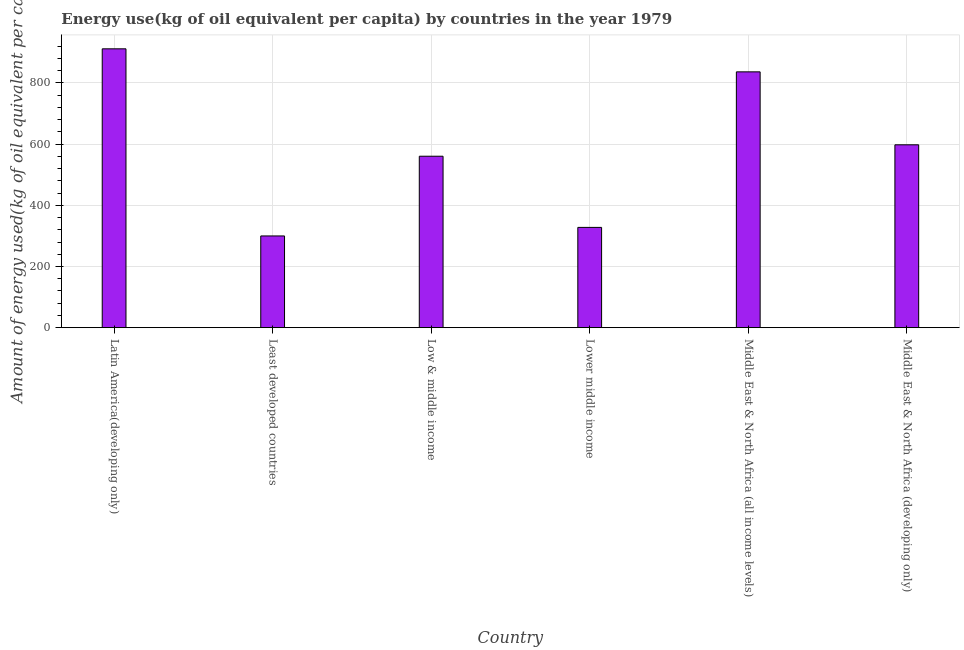Does the graph contain any zero values?
Provide a short and direct response. No. What is the title of the graph?
Provide a succinct answer. Energy use(kg of oil equivalent per capita) by countries in the year 1979. What is the label or title of the Y-axis?
Make the answer very short. Amount of energy used(kg of oil equivalent per capita). What is the amount of energy used in Middle East & North Africa (developing only)?
Your answer should be very brief. 597.81. Across all countries, what is the maximum amount of energy used?
Offer a very short reply. 911.58. Across all countries, what is the minimum amount of energy used?
Offer a terse response. 299.85. In which country was the amount of energy used maximum?
Offer a very short reply. Latin America(developing only). In which country was the amount of energy used minimum?
Your answer should be very brief. Least developed countries. What is the sum of the amount of energy used?
Provide a short and direct response. 3533.73. What is the difference between the amount of energy used in Latin America(developing only) and Low & middle income?
Your response must be concise. 351.13. What is the average amount of energy used per country?
Keep it short and to the point. 588.96. What is the median amount of energy used?
Give a very brief answer. 579.13. What is the ratio of the amount of energy used in Latin America(developing only) to that in Middle East & North Africa (developing only)?
Offer a very short reply. 1.52. Is the difference between the amount of energy used in Least developed countries and Middle East & North Africa (all income levels) greater than the difference between any two countries?
Offer a very short reply. No. What is the difference between the highest and the second highest amount of energy used?
Provide a short and direct response. 75.33. What is the difference between the highest and the lowest amount of energy used?
Your response must be concise. 611.73. How many bars are there?
Ensure brevity in your answer.  6. How many countries are there in the graph?
Ensure brevity in your answer.  6. Are the values on the major ticks of Y-axis written in scientific E-notation?
Offer a terse response. No. What is the Amount of energy used(kg of oil equivalent per capita) of Latin America(developing only)?
Your response must be concise. 911.58. What is the Amount of energy used(kg of oil equivalent per capita) in Least developed countries?
Offer a very short reply. 299.85. What is the Amount of energy used(kg of oil equivalent per capita) in Low & middle income?
Offer a terse response. 560.45. What is the Amount of energy used(kg of oil equivalent per capita) in Lower middle income?
Make the answer very short. 327.79. What is the Amount of energy used(kg of oil equivalent per capita) in Middle East & North Africa (all income levels)?
Your answer should be compact. 836.25. What is the Amount of energy used(kg of oil equivalent per capita) in Middle East & North Africa (developing only)?
Ensure brevity in your answer.  597.81. What is the difference between the Amount of energy used(kg of oil equivalent per capita) in Latin America(developing only) and Least developed countries?
Provide a succinct answer. 611.73. What is the difference between the Amount of energy used(kg of oil equivalent per capita) in Latin America(developing only) and Low & middle income?
Offer a terse response. 351.13. What is the difference between the Amount of energy used(kg of oil equivalent per capita) in Latin America(developing only) and Lower middle income?
Make the answer very short. 583.78. What is the difference between the Amount of energy used(kg of oil equivalent per capita) in Latin America(developing only) and Middle East & North Africa (all income levels)?
Your answer should be compact. 75.33. What is the difference between the Amount of energy used(kg of oil equivalent per capita) in Latin America(developing only) and Middle East & North Africa (developing only)?
Offer a terse response. 313.77. What is the difference between the Amount of energy used(kg of oil equivalent per capita) in Least developed countries and Low & middle income?
Make the answer very short. -260.6. What is the difference between the Amount of energy used(kg of oil equivalent per capita) in Least developed countries and Lower middle income?
Offer a terse response. -27.95. What is the difference between the Amount of energy used(kg of oil equivalent per capita) in Least developed countries and Middle East & North Africa (all income levels)?
Make the answer very short. -536.4. What is the difference between the Amount of energy used(kg of oil equivalent per capita) in Least developed countries and Middle East & North Africa (developing only)?
Keep it short and to the point. -297.96. What is the difference between the Amount of energy used(kg of oil equivalent per capita) in Low & middle income and Lower middle income?
Your answer should be compact. 232.65. What is the difference between the Amount of energy used(kg of oil equivalent per capita) in Low & middle income and Middle East & North Africa (all income levels)?
Offer a very short reply. -275.8. What is the difference between the Amount of energy used(kg of oil equivalent per capita) in Low & middle income and Middle East & North Africa (developing only)?
Offer a very short reply. -37.36. What is the difference between the Amount of energy used(kg of oil equivalent per capita) in Lower middle income and Middle East & North Africa (all income levels)?
Give a very brief answer. -508.46. What is the difference between the Amount of energy used(kg of oil equivalent per capita) in Lower middle income and Middle East & North Africa (developing only)?
Ensure brevity in your answer.  -270.01. What is the difference between the Amount of energy used(kg of oil equivalent per capita) in Middle East & North Africa (all income levels) and Middle East & North Africa (developing only)?
Provide a succinct answer. 238.45. What is the ratio of the Amount of energy used(kg of oil equivalent per capita) in Latin America(developing only) to that in Least developed countries?
Give a very brief answer. 3.04. What is the ratio of the Amount of energy used(kg of oil equivalent per capita) in Latin America(developing only) to that in Low & middle income?
Provide a succinct answer. 1.63. What is the ratio of the Amount of energy used(kg of oil equivalent per capita) in Latin America(developing only) to that in Lower middle income?
Make the answer very short. 2.78. What is the ratio of the Amount of energy used(kg of oil equivalent per capita) in Latin America(developing only) to that in Middle East & North Africa (all income levels)?
Ensure brevity in your answer.  1.09. What is the ratio of the Amount of energy used(kg of oil equivalent per capita) in Latin America(developing only) to that in Middle East & North Africa (developing only)?
Your answer should be very brief. 1.52. What is the ratio of the Amount of energy used(kg of oil equivalent per capita) in Least developed countries to that in Low & middle income?
Ensure brevity in your answer.  0.54. What is the ratio of the Amount of energy used(kg of oil equivalent per capita) in Least developed countries to that in Lower middle income?
Your response must be concise. 0.92. What is the ratio of the Amount of energy used(kg of oil equivalent per capita) in Least developed countries to that in Middle East & North Africa (all income levels)?
Ensure brevity in your answer.  0.36. What is the ratio of the Amount of energy used(kg of oil equivalent per capita) in Least developed countries to that in Middle East & North Africa (developing only)?
Provide a succinct answer. 0.5. What is the ratio of the Amount of energy used(kg of oil equivalent per capita) in Low & middle income to that in Lower middle income?
Offer a very short reply. 1.71. What is the ratio of the Amount of energy used(kg of oil equivalent per capita) in Low & middle income to that in Middle East & North Africa (all income levels)?
Your answer should be compact. 0.67. What is the ratio of the Amount of energy used(kg of oil equivalent per capita) in Low & middle income to that in Middle East & North Africa (developing only)?
Give a very brief answer. 0.94. What is the ratio of the Amount of energy used(kg of oil equivalent per capita) in Lower middle income to that in Middle East & North Africa (all income levels)?
Make the answer very short. 0.39. What is the ratio of the Amount of energy used(kg of oil equivalent per capita) in Lower middle income to that in Middle East & North Africa (developing only)?
Offer a very short reply. 0.55. What is the ratio of the Amount of energy used(kg of oil equivalent per capita) in Middle East & North Africa (all income levels) to that in Middle East & North Africa (developing only)?
Your answer should be compact. 1.4. 